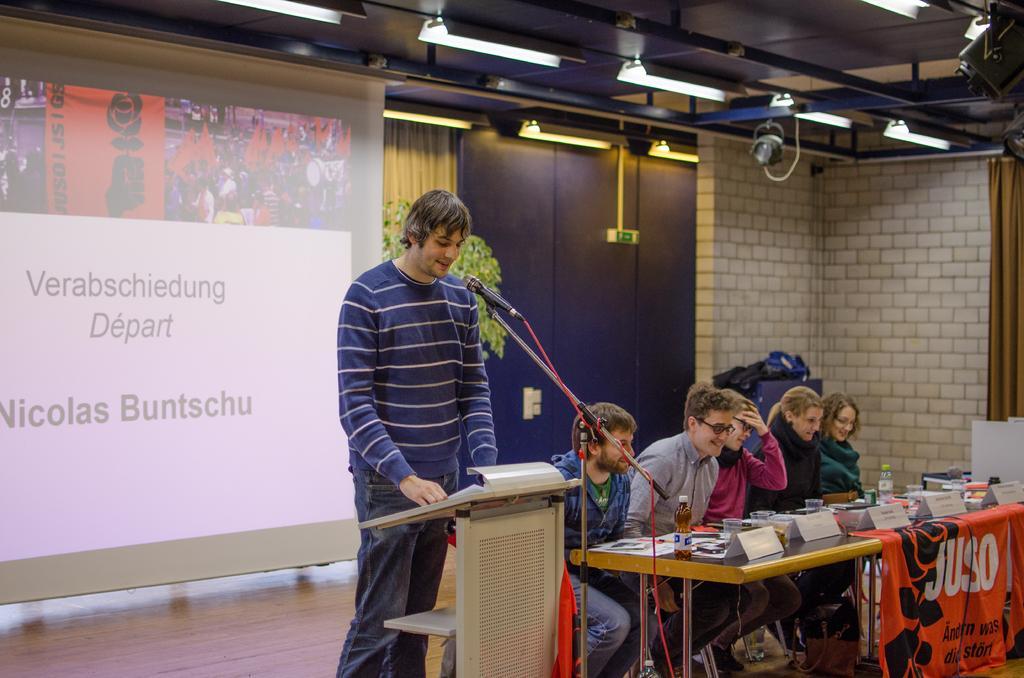In one or two sentences, can you explain what this image depicts? In this image I can see the group of people sitting on the chairs and one person is standing in front of the mic. There is a bottle,papers,banner on the table. At the back of them there is a screen. At the top there are some lights. And I can also see a plant at the back. 